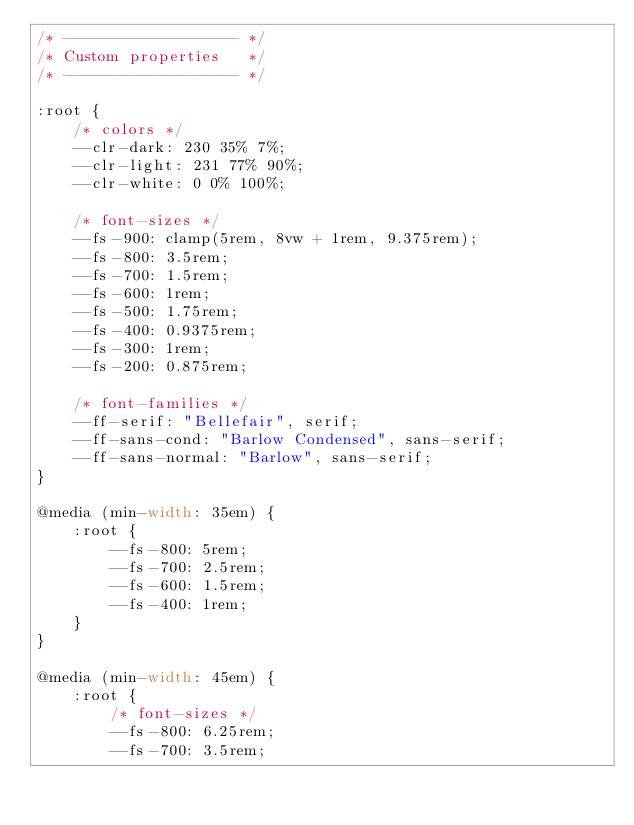<code> <loc_0><loc_0><loc_500><loc_500><_CSS_>/* ------------------- */
/* Custom properties   */
/* ------------------- */

:root {
    /* colors */
    --clr-dark: 230 35% 7%;
    --clr-light: 231 77% 90%;
    --clr-white: 0 0% 100%;
    
    /* font-sizes */
    --fs-900: clamp(5rem, 8vw + 1rem, 9.375rem);
    --fs-800: 3.5rem;
    --fs-700: 1.5rem;
    --fs-600: 1rem;
    --fs-500: 1.75rem;
    --fs-400: 0.9375rem;
    --fs-300: 1rem;
    --fs-200: 0.875rem;
    
    /* font-families */
    --ff-serif: "Bellefair", serif;
    --ff-sans-cond: "Barlow Condensed", sans-serif;
    --ff-sans-normal: "Barlow", sans-serif;
}

@media (min-width: 35em) {
    :root {
        --fs-800: 5rem;
        --fs-700: 2.5rem;
        --fs-600: 1.5rem;
        --fs-400: 1rem;
    }
}

@media (min-width: 45em) {
    :root {
        /* font-sizes */
        --fs-800: 6.25rem;
        --fs-700: 3.5rem;</code> 